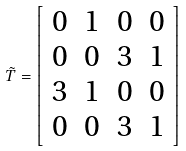<formula> <loc_0><loc_0><loc_500><loc_500>\tilde { T } = \left [ \begin{array} { c c c c } 0 & 1 & 0 & 0 \\ 0 & 0 & 3 & 1 \\ 3 & 1 & 0 & 0 \\ 0 & 0 & 3 & 1 \end{array} \right ]</formula> 